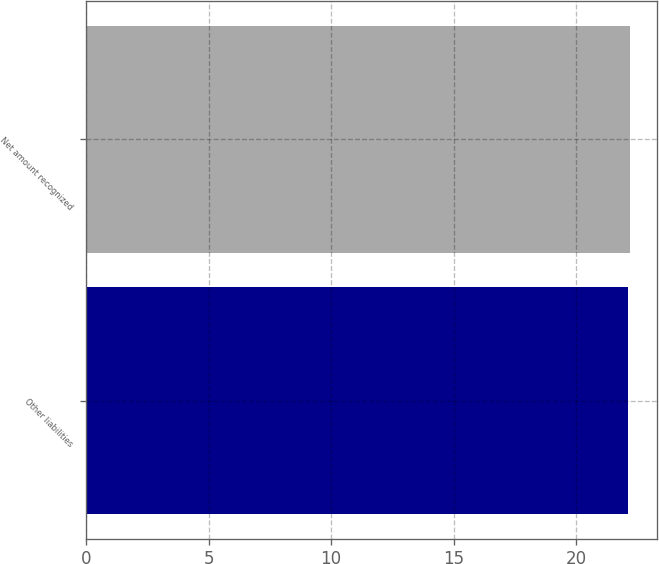Convert chart to OTSL. <chart><loc_0><loc_0><loc_500><loc_500><bar_chart><fcel>Other liabilities<fcel>Net amount recognized<nl><fcel>22.1<fcel>22.2<nl></chart> 